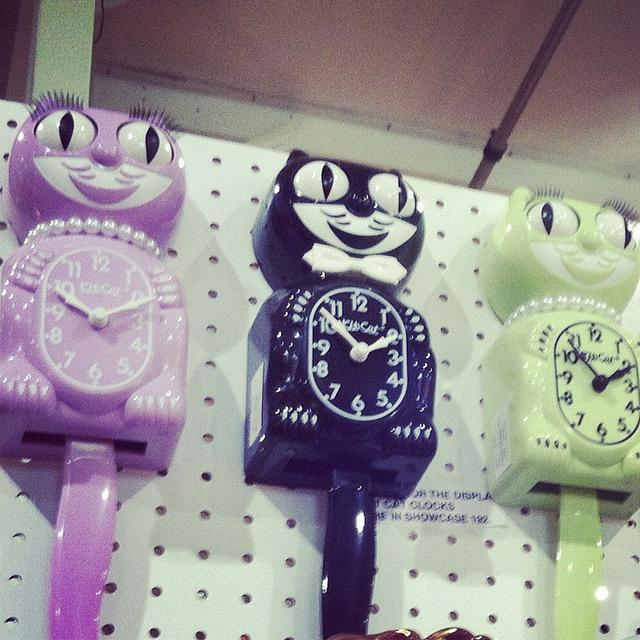How many clocks can be seen?
Give a very brief answer. 3. 